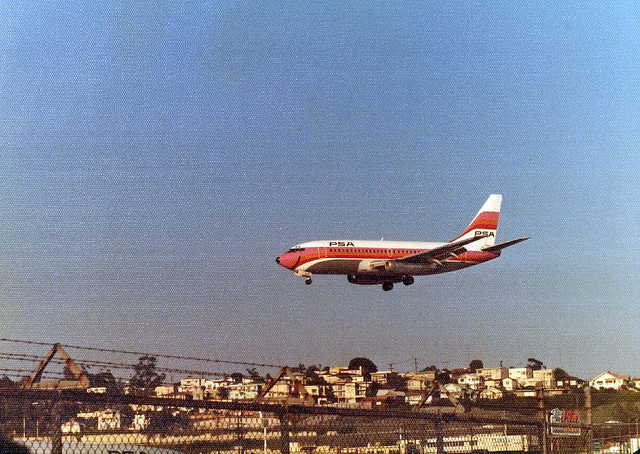Can you describe the surroundings where the airplane is flying? The airplane is flying above a residential area with several houses visible. It appears to be low in the sky, possibly approaching or departing from an airport. The setting is urban, and it seems to be daytime given the lighting in the photo. 